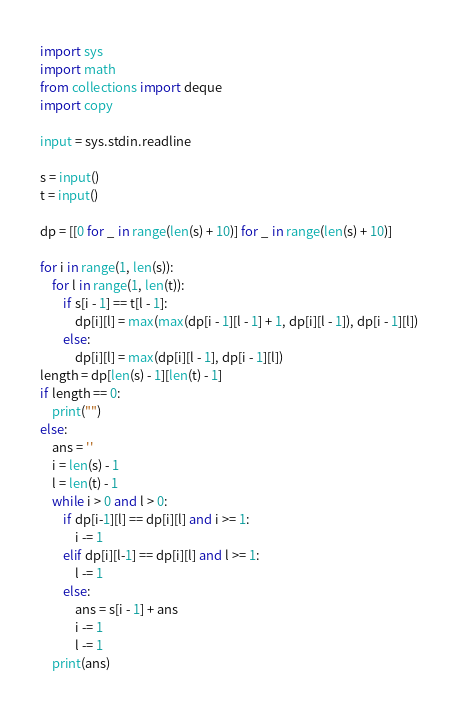Convert code to text. <code><loc_0><loc_0><loc_500><loc_500><_Python_>import sys
import math
from collections import deque
import copy

input = sys.stdin.readline

s = input()
t = input()

dp = [[0 for _ in range(len(s) + 10)] for _ in range(len(s) + 10)]

for i in range(1, len(s)):
    for l in range(1, len(t)):
        if s[i - 1] == t[l - 1]:
            dp[i][l] = max(max(dp[i - 1][l - 1] + 1, dp[i][l - 1]), dp[i - 1][l])
        else:
            dp[i][l] = max(dp[i][l - 1], dp[i - 1][l])
length = dp[len(s) - 1][len(t) - 1]
if length == 0:
    print("")
else:
    ans = ''
    i = len(s) - 1
    l = len(t) - 1
    while i > 0 and l > 0:
        if dp[i-1][l] == dp[i][l] and i >= 1:
            i -= 1
        elif dp[i][l-1] == dp[i][l] and l >= 1:
            l -= 1
        else:
            ans = s[i - 1] + ans
            i -= 1
            l -= 1
    print(ans)
</code> 